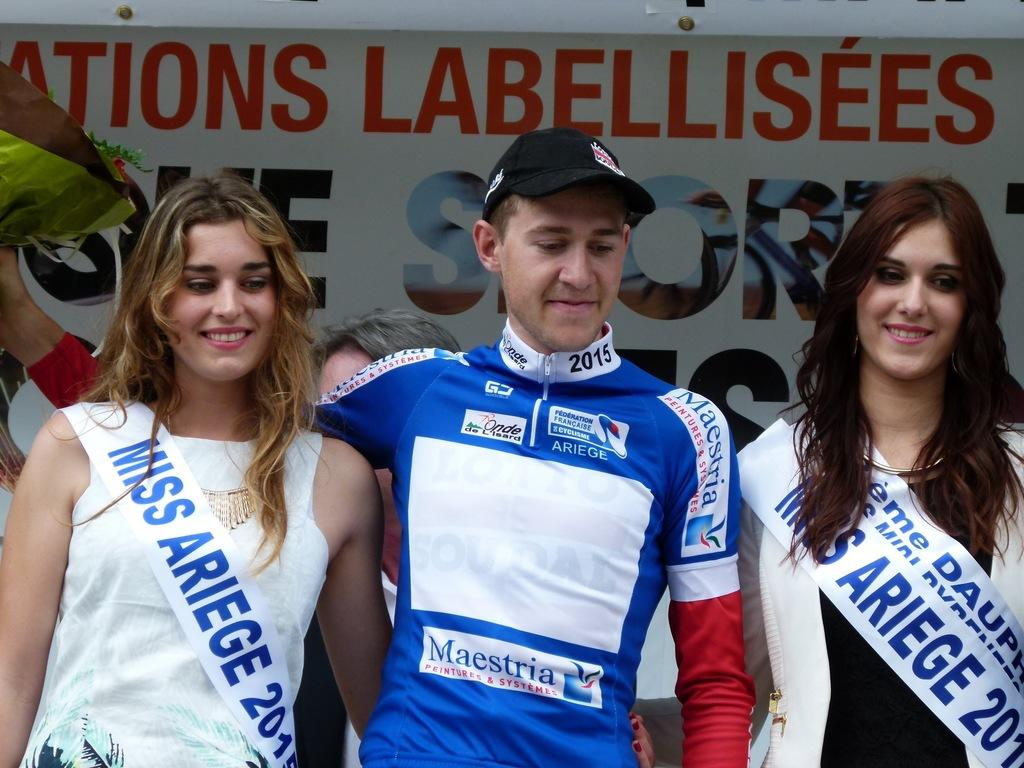<image>
Present a compact description of the photo's key features. A man wears a shirt with the year 2015 on the color. 